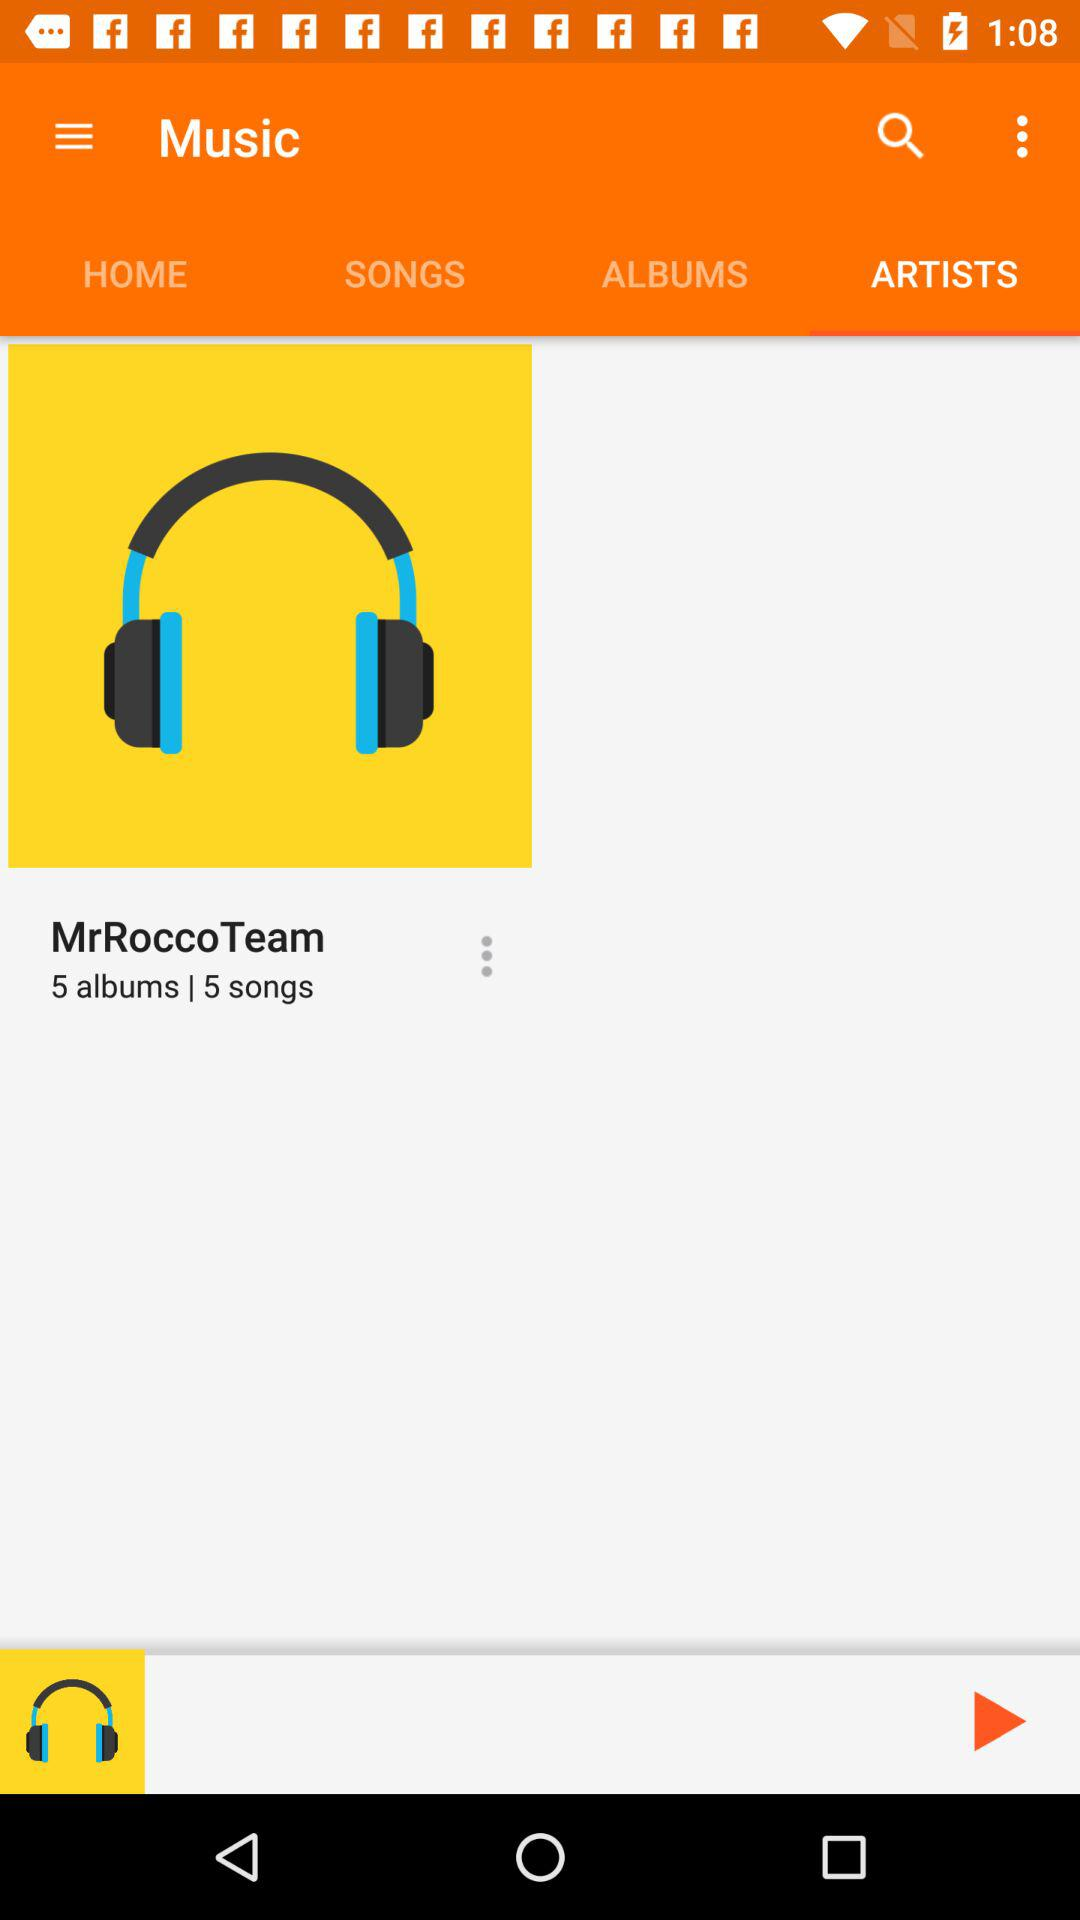How many more songs does MrRoccoTeam have than albums?
Answer the question using a single word or phrase. 0 